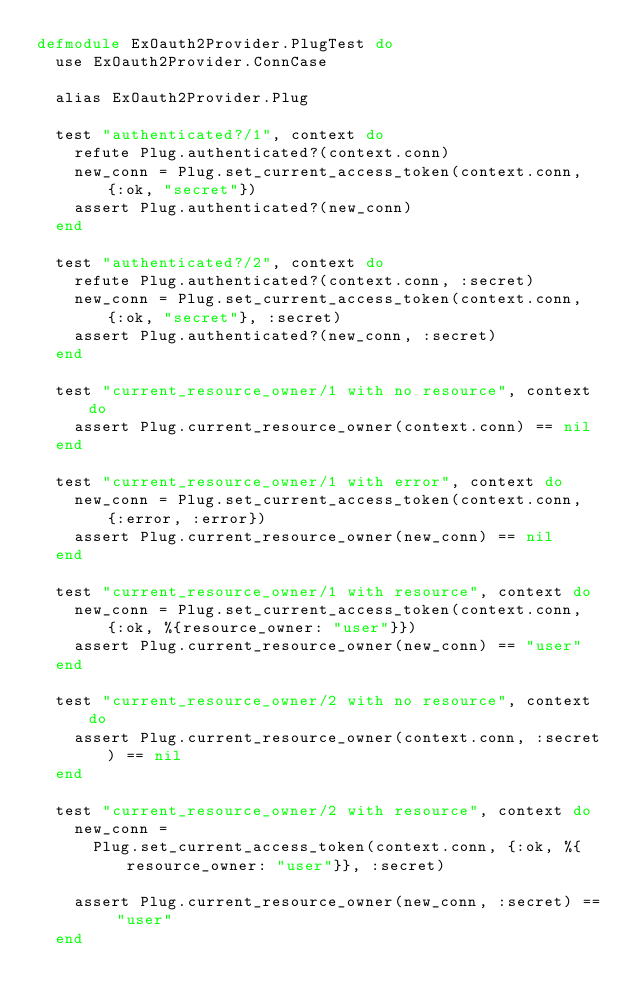Convert code to text. <code><loc_0><loc_0><loc_500><loc_500><_Elixir_>defmodule ExOauth2Provider.PlugTest do
  use ExOauth2Provider.ConnCase

  alias ExOauth2Provider.Plug

  test "authenticated?/1", context do
    refute Plug.authenticated?(context.conn)
    new_conn = Plug.set_current_access_token(context.conn, {:ok, "secret"})
    assert Plug.authenticated?(new_conn)
  end

  test "authenticated?/2", context do
    refute Plug.authenticated?(context.conn, :secret)
    new_conn = Plug.set_current_access_token(context.conn, {:ok, "secret"}, :secret)
    assert Plug.authenticated?(new_conn, :secret)
  end

  test "current_resource_owner/1 with no resource", context do
    assert Plug.current_resource_owner(context.conn) == nil
  end

  test "current_resource_owner/1 with error", context do
    new_conn = Plug.set_current_access_token(context.conn, {:error, :error})
    assert Plug.current_resource_owner(new_conn) == nil
  end

  test "current_resource_owner/1 with resource", context do
    new_conn = Plug.set_current_access_token(context.conn, {:ok, %{resource_owner: "user"}})
    assert Plug.current_resource_owner(new_conn) == "user"
  end

  test "current_resource_owner/2 with no resource", context do
    assert Plug.current_resource_owner(context.conn, :secret) == nil
  end

  test "current_resource_owner/2 with resource", context do
    new_conn =
      Plug.set_current_access_token(context.conn, {:ok, %{resource_owner: "user"}}, :secret)

    assert Plug.current_resource_owner(new_conn, :secret) == "user"
  end
</code> 